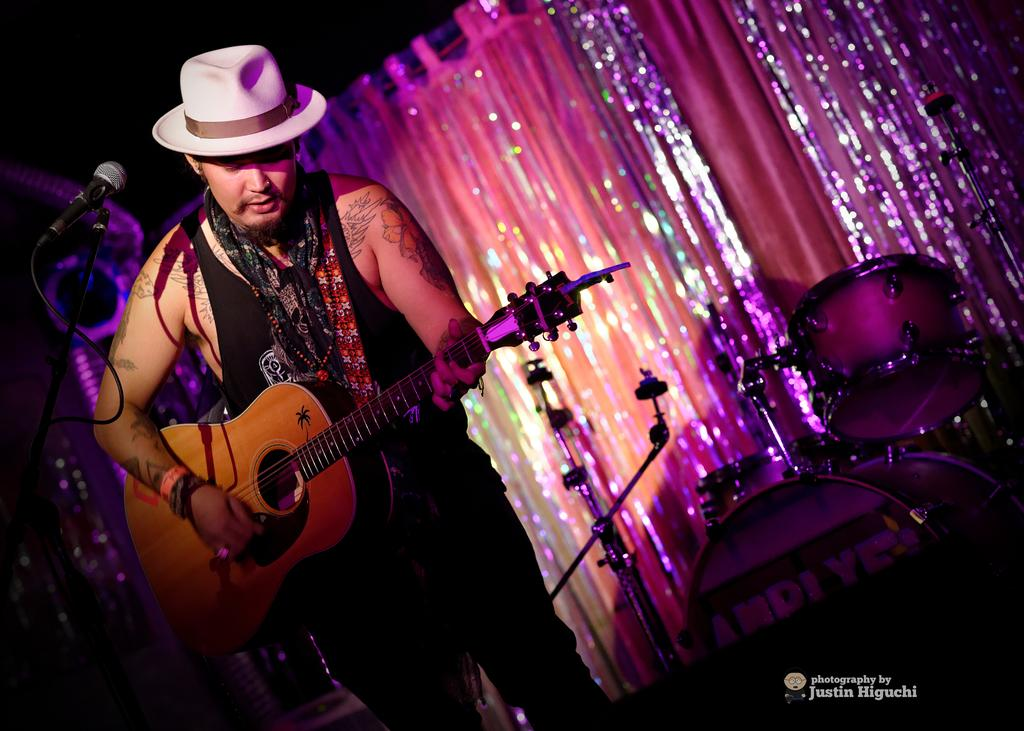What is the main subject of the image? The main subject of the image is a man. What is the man doing in the image? The man is standing and playing the guitar. Can you describe the man's attire in the image? The man is wearing a hat. What type of leather material can be seen on the crow in the image? There is no crow present in the image, and therefore no leather material can be observed. 